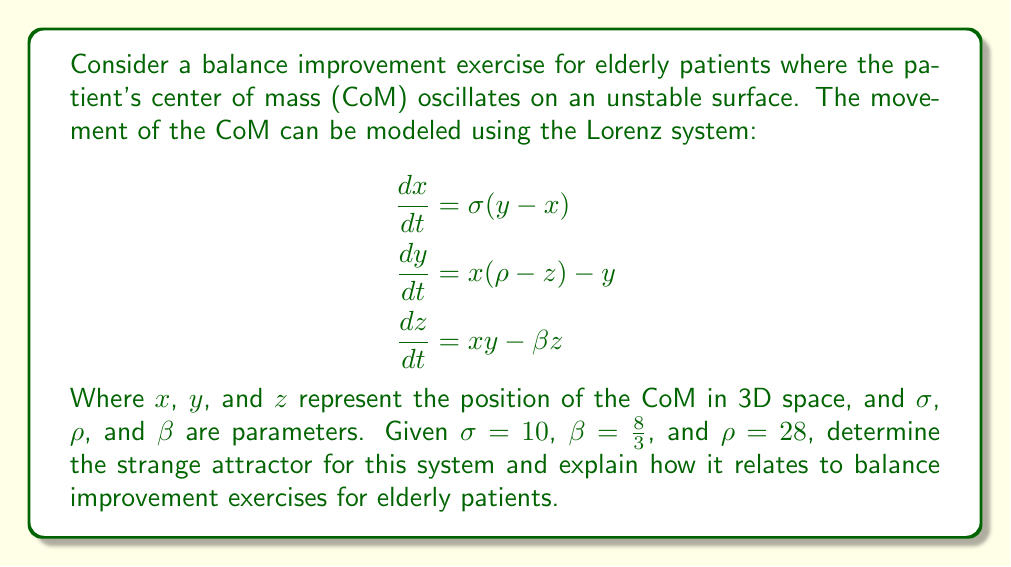Help me with this question. To determine the strange attractor for this system and relate it to balance improvement exercises, we'll follow these steps:

1) First, we recognize that the given equations form the Lorenz system, which is known to produce a strange attractor called the Lorenz attractor.

2) The Lorenz attractor is characterized by its butterfly-like shape in 3D space. It has two main lobes, with trajectories that spiral around fixed points in each lobe before switching to the other lobe.

3) To visualize the attractor, we would typically need to solve the differential equations numerically and plot the results. However, given the parameters $\sigma=10$, $\beta=8/3$, and $\rho=28$, we know that these values produce the classic Lorenz attractor.

4) The strange attractor in this case represents the long-term behavior of the patient's CoM during the balance exercise. Each point on the attractor corresponds to a possible state of the system (position of the CoM).

5) The two lobes of the attractor can be interpreted as two main positions or strategies that the patient's body tends to use for maintaining balance. The switching between lobes represents the body's adjustment and rebalancing.

6) The fractal nature of the attractor implies that the patient's balance adjustments occur on multiple scales, from small, quick adjustments to larger shifts in posture.

7) The sensitivity to initial conditions (a hallmark of chaos) suggests that small perturbations in the patient's position can lead to significantly different trajectories over time. This mimics the unpredictable nature of real-world balance challenges.

8) For elderly patients, this model suggests that balance improvement exercises should:
   a) Encourage movement between different balance strategies (represented by the two lobes)
   b) Include both small and large balance adjustments
   c) Introduce unpredictable perturbations to improve adaptability

9) The non-repeating nature of the trajectories on the attractor implies that the exercise promotes continuous, varied movements rather than repetitive, predictable ones.

10) The bounded nature of the attractor suggests that while the CoM moves in complex patterns, it remains within a safe range, which is crucial for elderly patients to prevent falls.
Answer: The Lorenz attractor: a butterfly-shaped strange attractor representing complex, bounded CoM movements between two main balance strategies. 